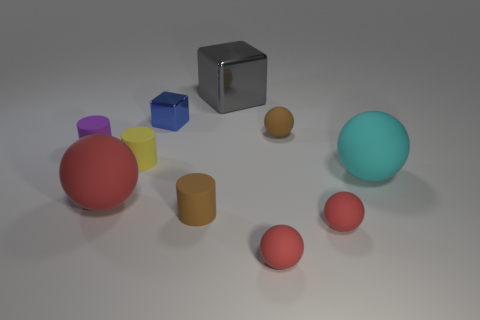How many gray objects have the same material as the blue thing?
Give a very brief answer. 1. There is a rubber object that is behind the large cyan matte thing and in front of the small purple cylinder; what shape is it?
Offer a very short reply. Cylinder. How many things are either big things in front of the cyan ball or rubber things that are behind the cyan matte ball?
Give a very brief answer. 4. Are there the same number of purple objects that are on the right side of the gray thing and small cubes that are to the left of the big red object?
Keep it short and to the point. Yes. What shape is the brown object that is in front of the big thing on the left side of the big gray metal thing?
Give a very brief answer. Cylinder. Are there any small blue metal objects of the same shape as the gray thing?
Your answer should be very brief. Yes. What number of big yellow blocks are there?
Make the answer very short. 0. Are the tiny brown object that is on the right side of the gray metal cube and the blue thing made of the same material?
Provide a short and direct response. No. Are there any red matte things that have the same size as the yellow rubber cylinder?
Offer a very short reply. Yes. Is the shape of the purple rubber thing the same as the brown matte thing in front of the cyan object?
Your answer should be very brief. Yes. 